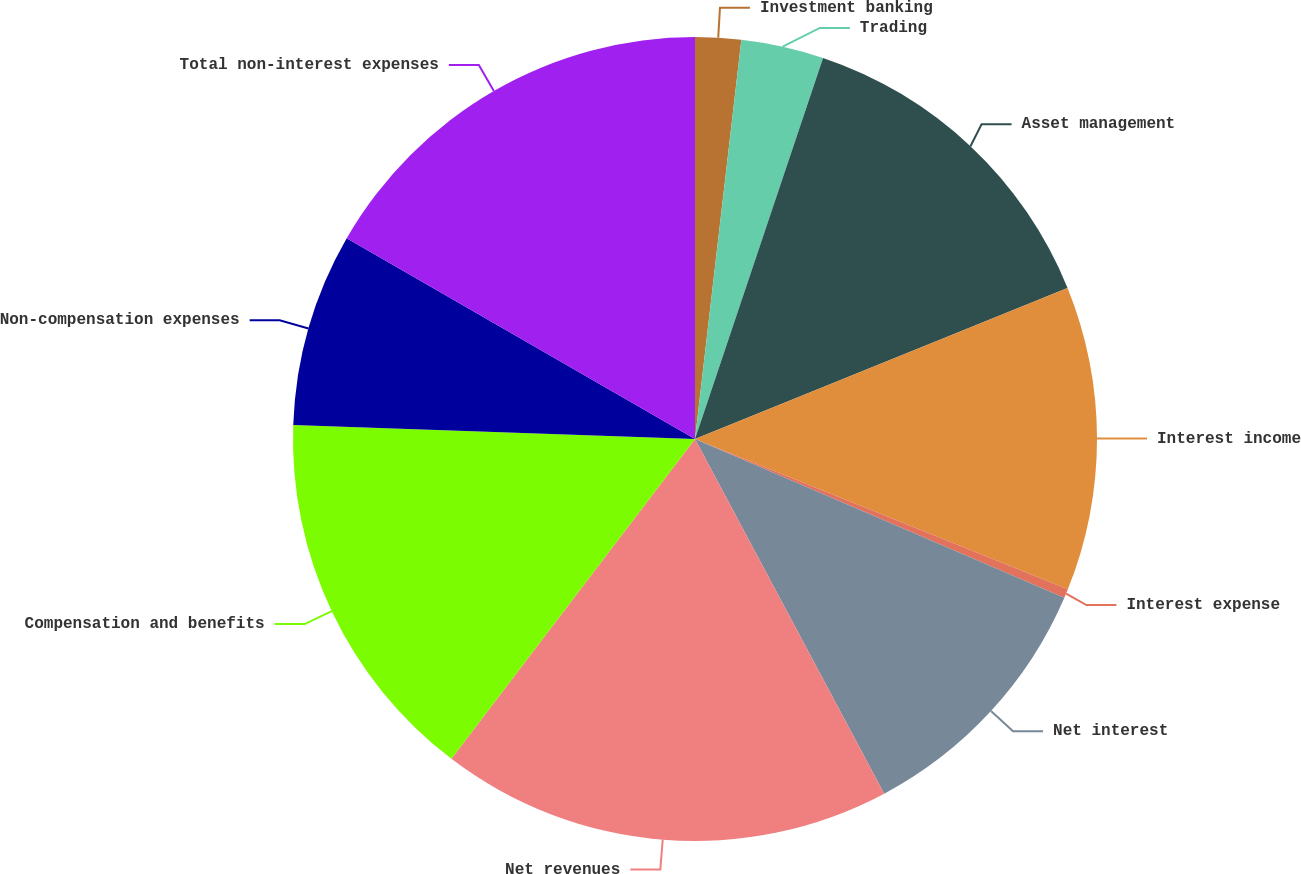Convert chart. <chart><loc_0><loc_0><loc_500><loc_500><pie_chart><fcel>Investment banking<fcel>Trading<fcel>Asset management<fcel>Interest income<fcel>Interest expense<fcel>Net interest<fcel>Net revenues<fcel>Compensation and benefits<fcel>Non-compensation expenses<fcel>Total non-interest expenses<nl><fcel>1.84%<fcel>3.32%<fcel>13.71%<fcel>12.23%<fcel>0.36%<fcel>10.74%<fcel>18.16%<fcel>15.19%<fcel>7.77%<fcel>16.68%<nl></chart> 